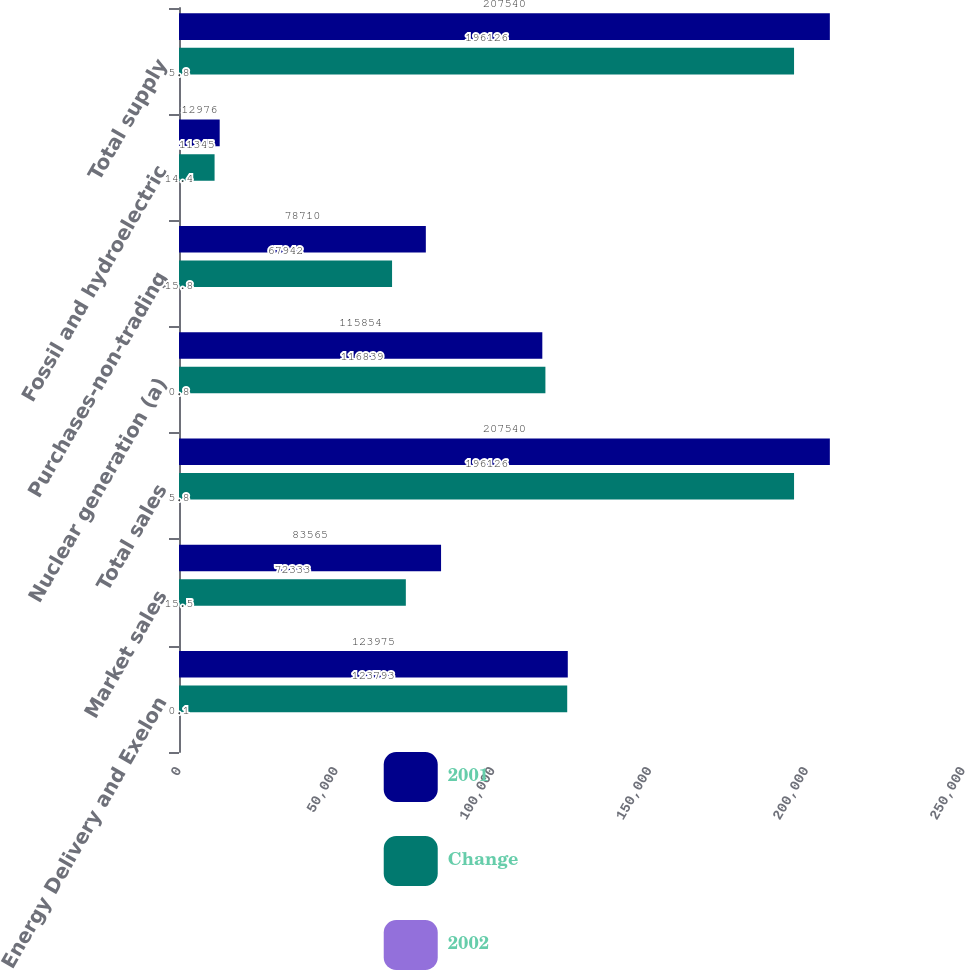<chart> <loc_0><loc_0><loc_500><loc_500><stacked_bar_chart><ecel><fcel>Energy Delivery and Exelon<fcel>Market sales<fcel>Total sales<fcel>Nuclear generation (a)<fcel>Purchases-non-trading<fcel>Fossil and hydroelectric<fcel>Total supply<nl><fcel>2001<fcel>123975<fcel>83565<fcel>207540<fcel>115854<fcel>78710<fcel>12976<fcel>207540<nl><fcel>Change<fcel>123793<fcel>72333<fcel>196126<fcel>116839<fcel>67942<fcel>11345<fcel>196126<nl><fcel>2002<fcel>0.1<fcel>15.5<fcel>5.8<fcel>0.8<fcel>15.8<fcel>14.4<fcel>5.8<nl></chart> 